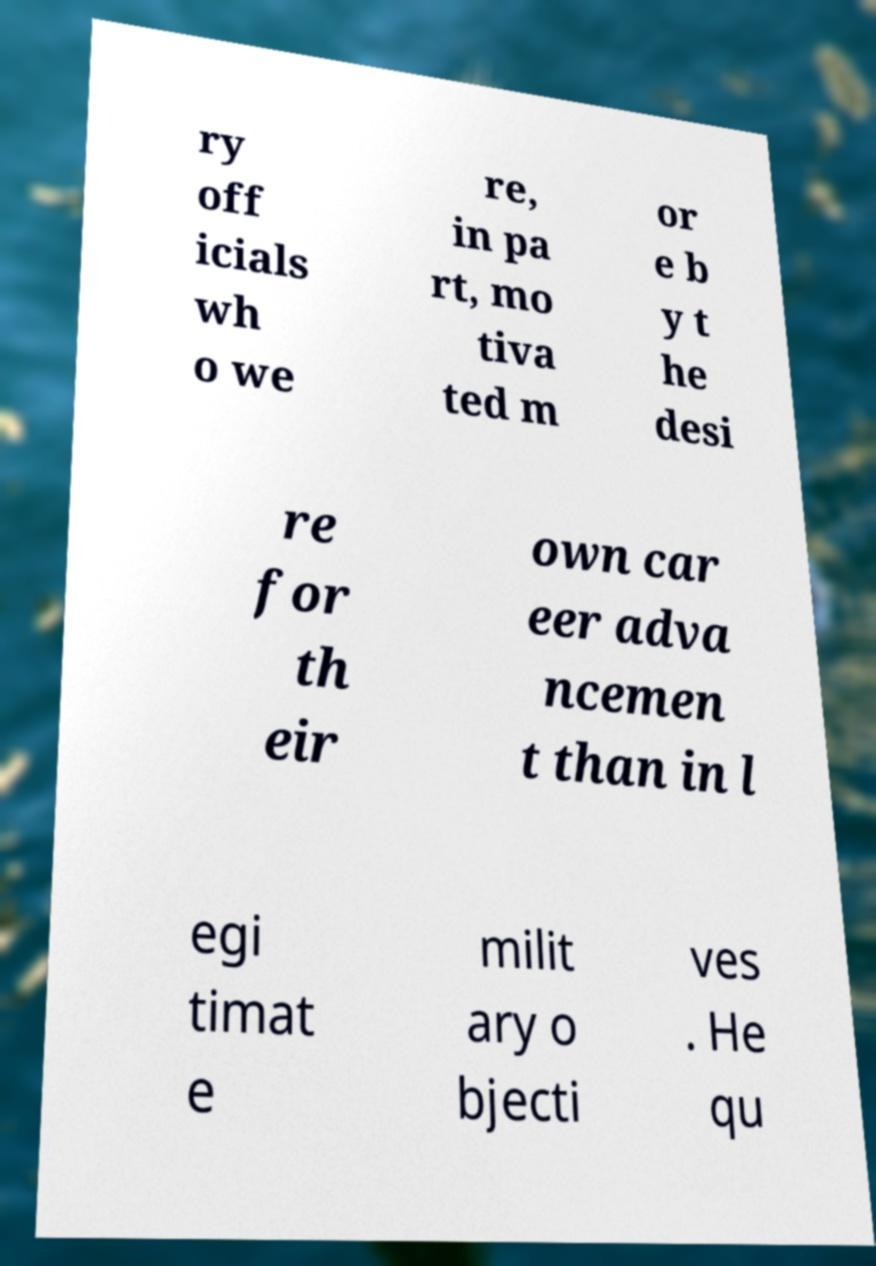I need the written content from this picture converted into text. Can you do that? ry off icials wh o we re, in pa rt, mo tiva ted m or e b y t he desi re for th eir own car eer adva ncemen t than in l egi timat e milit ary o bjecti ves . He qu 